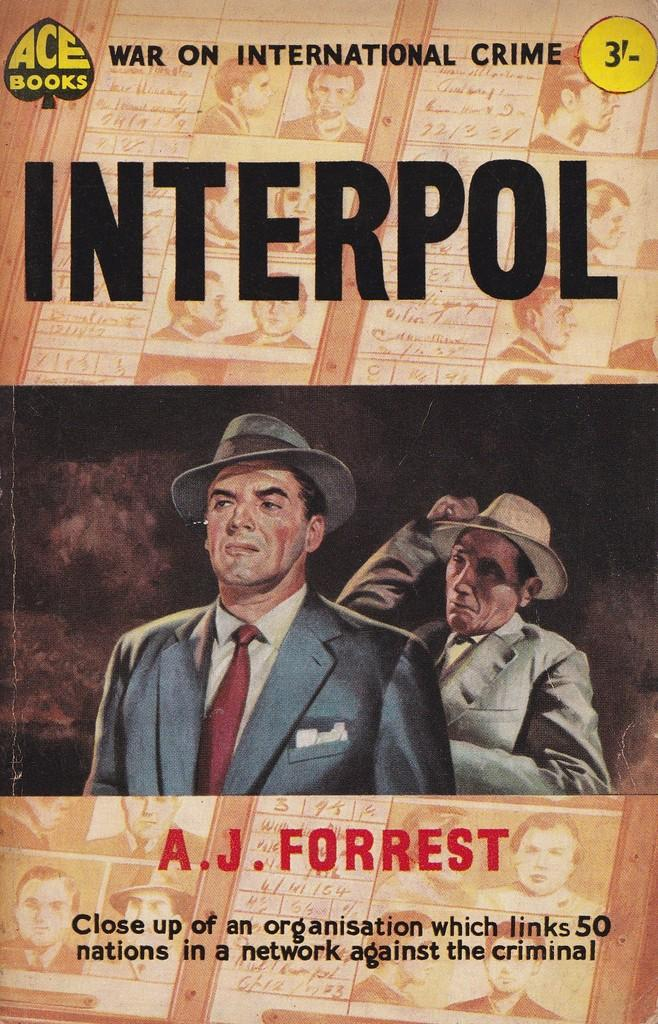What is featured in the image? There is a poster in the image. What can be seen on the poster? There is writing on the poster. How many people are in the image? There are two persons in the image. What are the two persons wearing? The two persons are wearing hats. What is the tendency of the team in the image? There is no team present in the image, so it's not possible to determine any tendencies. 